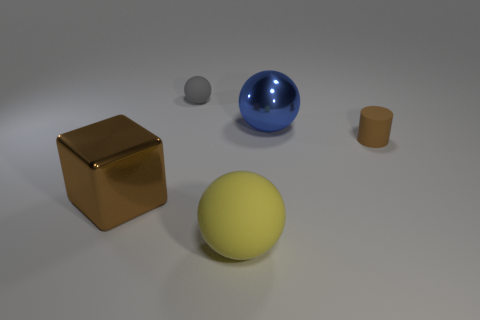There is a big shiny ball; is it the same color as the rubber ball that is behind the big brown metal block?
Your answer should be very brief. No. Is there a cube behind the sphere on the left side of the big yellow thing in front of the large shiny cube?
Offer a terse response. No. What is the shape of the brown object that is the same material as the yellow sphere?
Your answer should be very brief. Cylinder. Is there anything else that has the same shape as the large brown object?
Provide a short and direct response. No. What is the shape of the brown rubber thing?
Make the answer very short. Cylinder. There is a small thing that is behind the brown matte cylinder; is its shape the same as the brown rubber object?
Offer a terse response. No. Are there more gray things to the right of the blue metallic ball than brown blocks that are in front of the small ball?
Your answer should be compact. No. What number of other things are there of the same size as the yellow rubber sphere?
Your answer should be compact. 2. Is the shape of the large yellow matte object the same as the brown thing on the right side of the tiny matte ball?
Your answer should be very brief. No. What number of rubber things are small brown objects or blue cylinders?
Offer a very short reply. 1. 